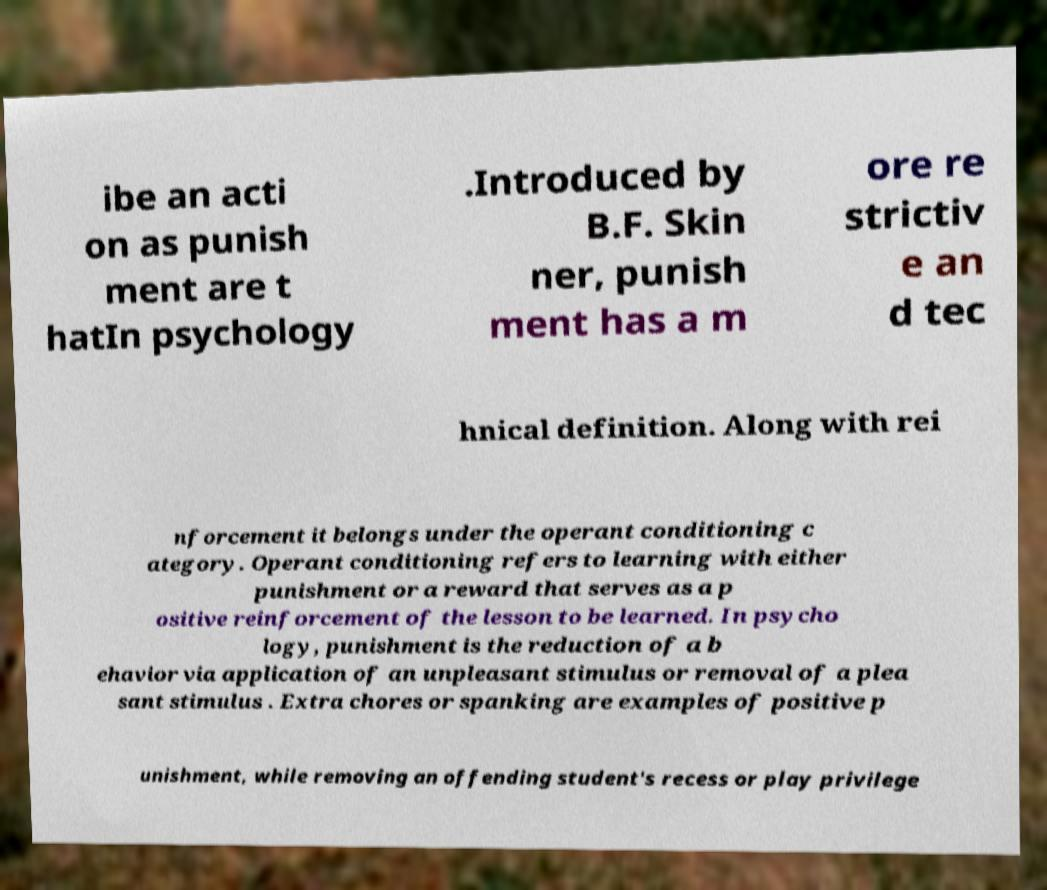I need the written content from this picture converted into text. Can you do that? ibe an acti on as punish ment are t hatIn psychology .Introduced by B.F. Skin ner, punish ment has a m ore re strictiv e an d tec hnical definition. Along with rei nforcement it belongs under the operant conditioning c ategory. Operant conditioning refers to learning with either punishment or a reward that serves as a p ositive reinforcement of the lesson to be learned. In psycho logy, punishment is the reduction of a b ehavior via application of an unpleasant stimulus or removal of a plea sant stimulus . Extra chores or spanking are examples of positive p unishment, while removing an offending student's recess or play privilege 